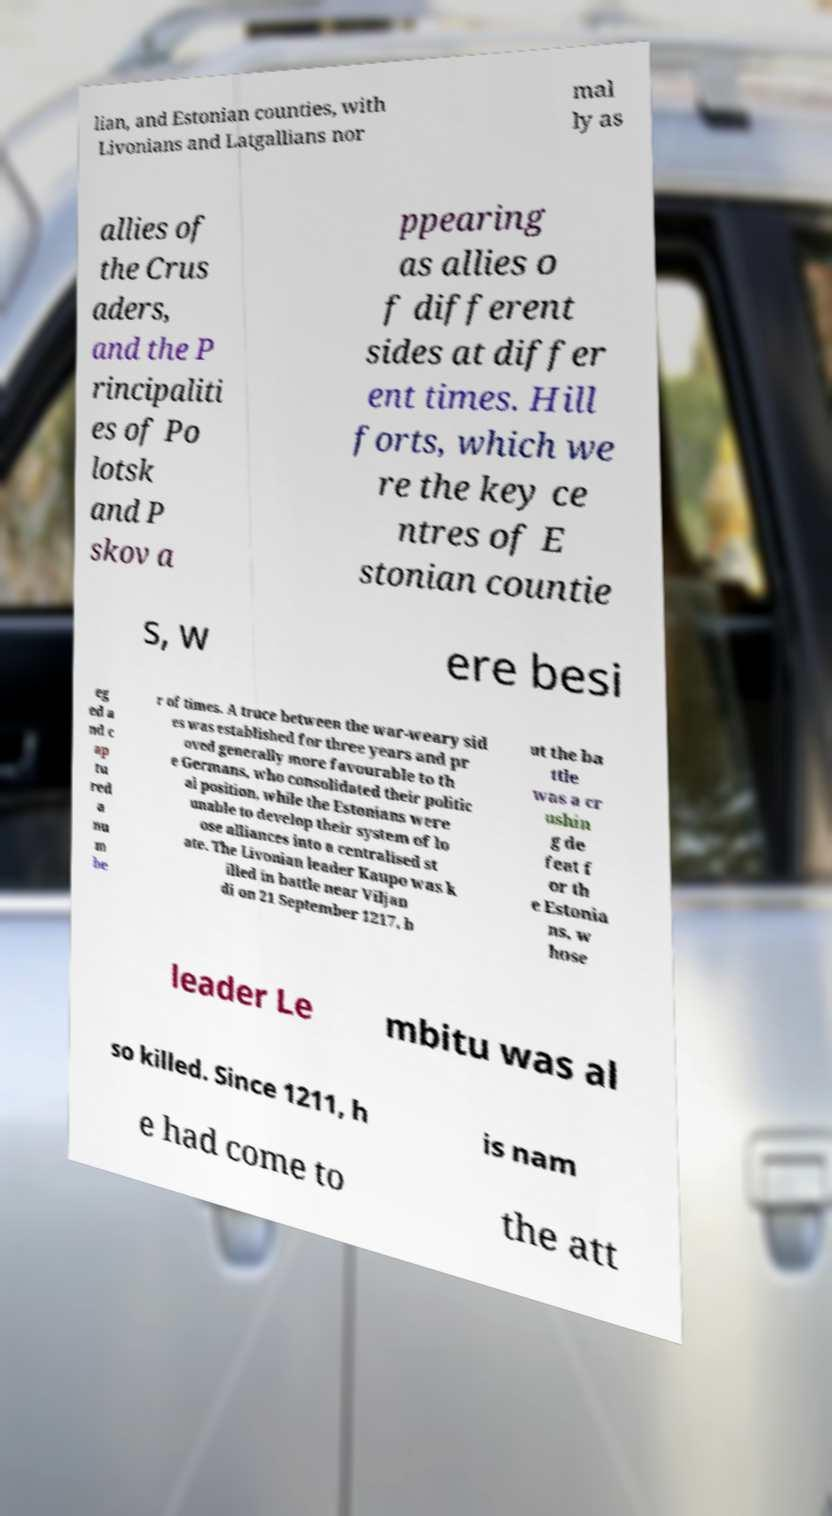There's text embedded in this image that I need extracted. Can you transcribe it verbatim? lian, and Estonian counties, with Livonians and Latgallians nor mal ly as allies of the Crus aders, and the P rincipaliti es of Po lotsk and P skov a ppearing as allies o f different sides at differ ent times. Hill forts, which we re the key ce ntres of E stonian countie s, w ere besi eg ed a nd c ap tu red a nu m be r of times. A truce between the war-weary sid es was established for three years and pr oved generally more favourable to th e Germans, who consolidated their politic al position, while the Estonians were unable to develop their system of lo ose alliances into a centralised st ate. The Livonian leader Kaupo was k illed in battle near Viljan di on 21 September 1217, b ut the ba ttle was a cr ushin g de feat f or th e Estonia ns, w hose leader Le mbitu was al so killed. Since 1211, h is nam e had come to the att 